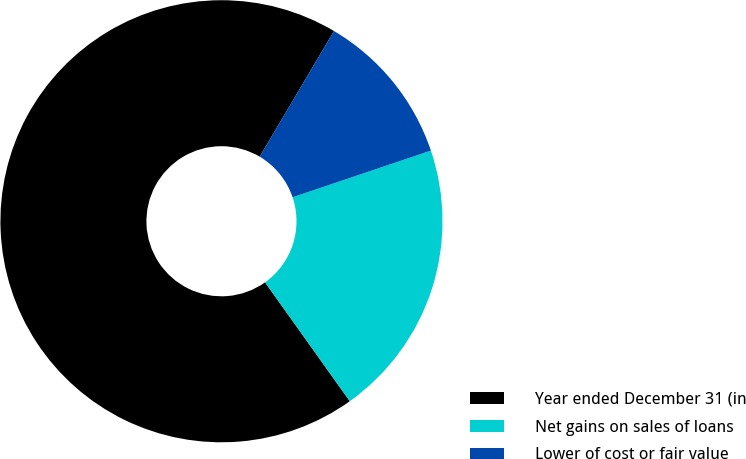Convert chart. <chart><loc_0><loc_0><loc_500><loc_500><pie_chart><fcel>Year ended December 31 (in<fcel>Net gains on sales of loans<fcel>Lower of cost or fair value<nl><fcel>68.36%<fcel>20.32%<fcel>11.32%<nl></chart> 